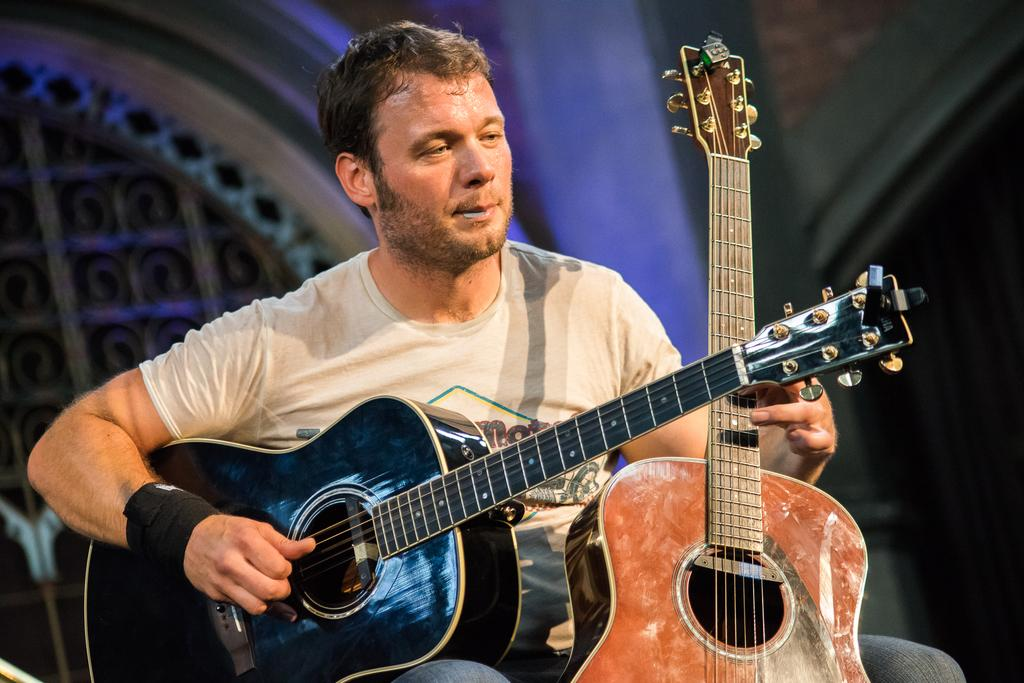What is the main subject of the image? There is a person in the image. What is the person doing in the image? The person is playing two guitars. What can be seen in the background of the image? There is a building in the background of the image. What type of distribution system is being used to transport the guitars in the image? There is no distribution system present in the image; the person is playing two guitars that are in their hands. 